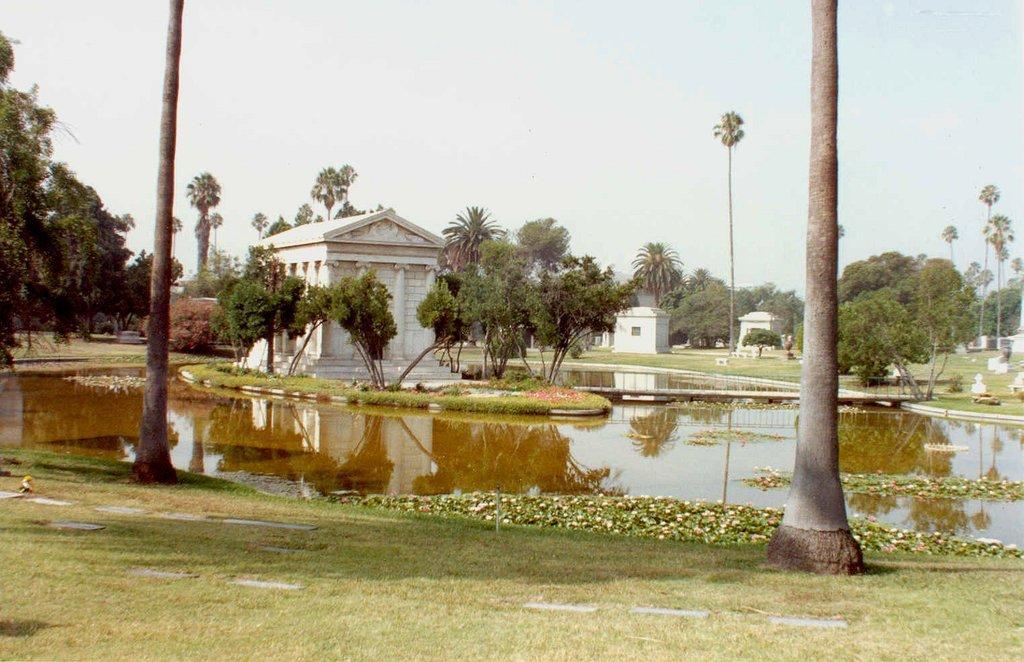Could you give a brief overview of what you see in this image? This is water. Here we can see trees, plants, and houses. This is grass. In the background there is sky. 